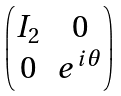<formula> <loc_0><loc_0><loc_500><loc_500>\begin{pmatrix} I _ { 2 } & 0 \\ 0 & e ^ { i \theta } \end{pmatrix}</formula> 